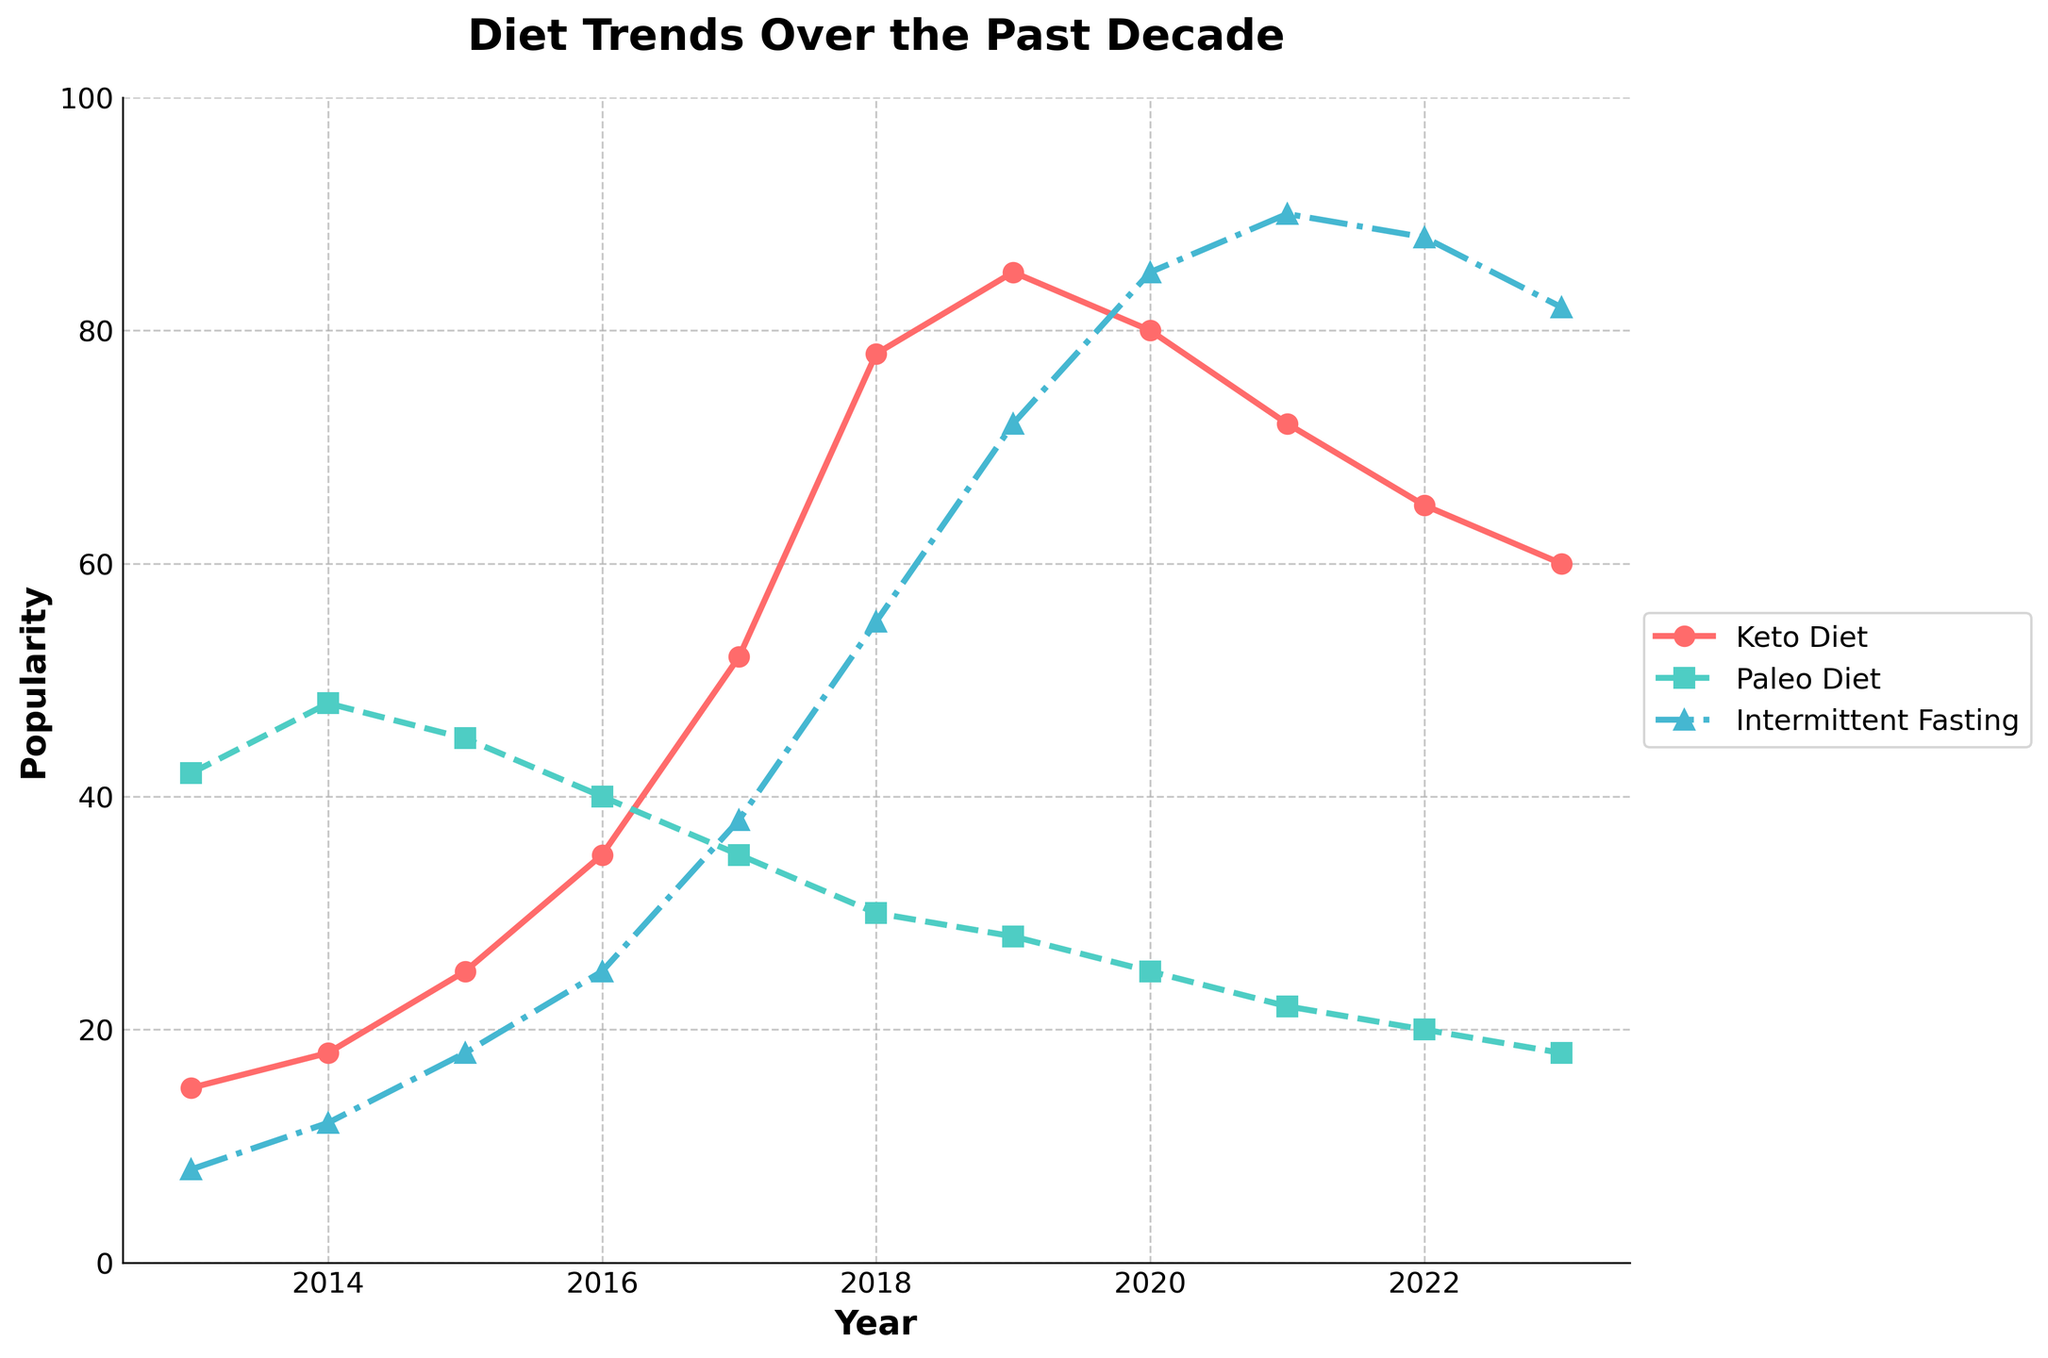what year did the keto diet see the highest popularity? The line for the keto diet peaks in 2019, so that year shows the highest popularity for the keto diet.
Answer: 2019 when did intermittent fasting surpass paleo in popularity? By comparing the plots, intermittent fasting surpasses paleo in 2017, as the line for intermittent fasting is higher than the paleo line from 2017 onward.
Answer: 2017 compare the popularity of keto and paleo diets in 2020. which one was more popular and by how much? In 2020, the popularity of the keto diet was 80, while the paleo diet was 25. Subtracting these values, 80 - 25 = 55, so the keto diet was more popular by 55 points.
Answer: Keto was more popular by 55 what is the trend for intermittent fasting from 2013 to 2023? The line for intermittent fasting shows an upward trend from 2013 to 2021, peaking in 2021 at 90, and then slightly declining to 82 in 2023.
Answer: Upward trend which diet had the steepest increase in popularity between 2016 and 2017? By observing the slopes of the lines, keto diet increased from 35 to 52 (a difference of 17), paleo decreased, and intermittent fasting increased from 25 to 38 (a difference of 13). Therefore, the keto diet had the steepest increase.
Answer: Keto what is the difference in popularity between keto and intermittent fasting in 2022? In 2022, the popularity of the keto diet was 65, while intermittent fasting was 88. The difference is 88 - 65 = 23.
Answer: 23 which diet trend was the least popular at the start of the decade? In 2013, paleo diet had a popularity of 42, keto 15, and intermittent fasting 8. Intermittent fasting was the least popular.
Answer: Intermittent fasting between 2017 and 2018, how much did keto's popularity increase? In 2017, keto's popularity was 52, and in 2018 it was 78. The increase is 78 - 52 = 26.
Answer: 26 what was the average popularity of the paleo diet over the decade? Adding all the paleo values (42+48+45+40+35+30+28+25+22+20+18) gets 353. Dividing by the number of years (11) gives approximately 32.09.
Answer: 32.09 how does the trend for paleo diet differ compared to keto and intermittent fasting? The paleo diet shows a consistent decline in popularity from 2014, while both keto and intermittent fasting show upward trends initially, with keto peaking in 2019 and intermittent fasting peaking in 2021.
Answer: Consistent decline 